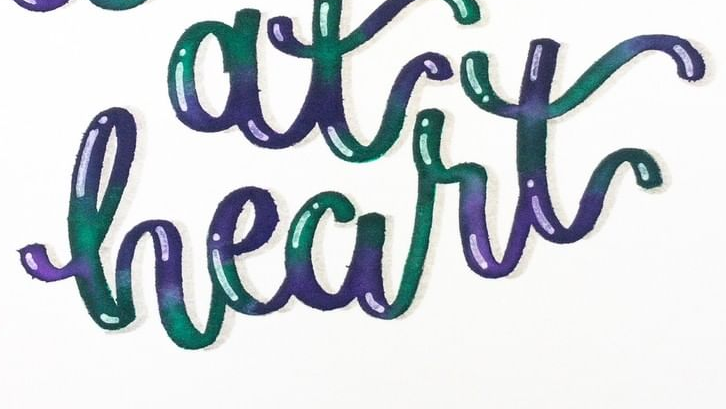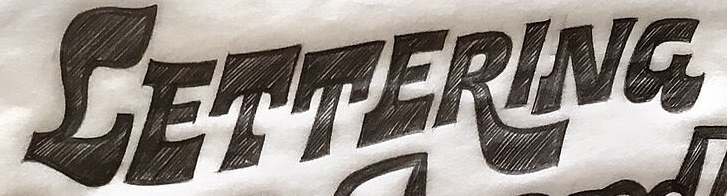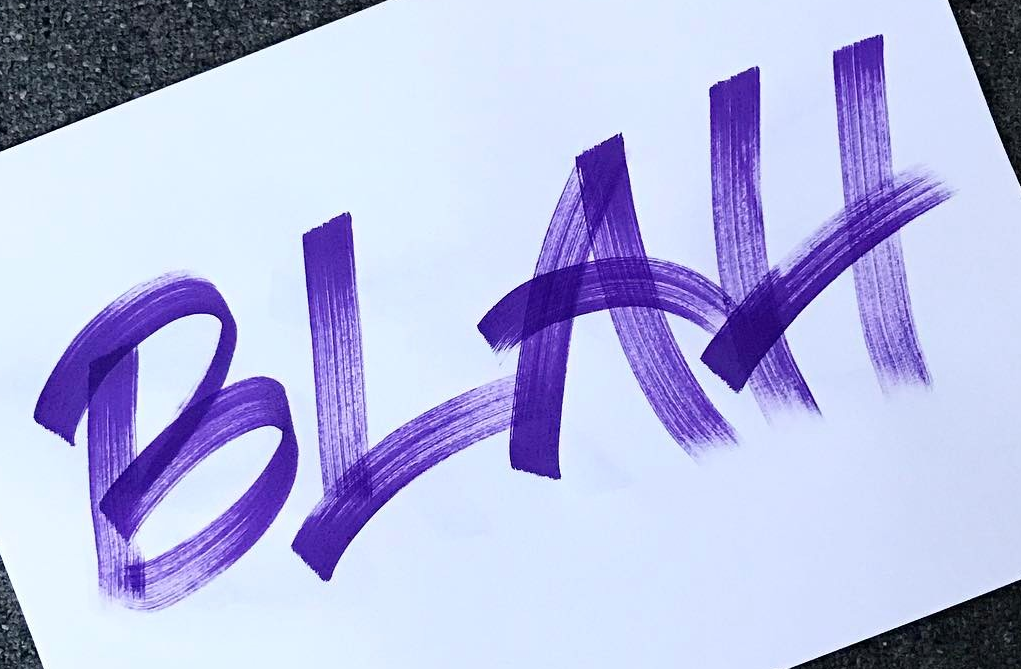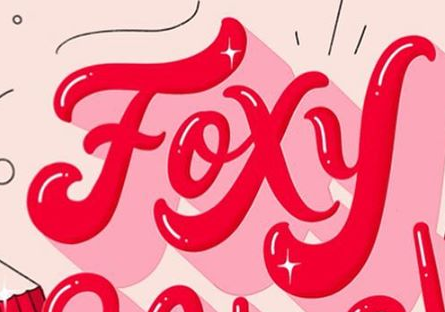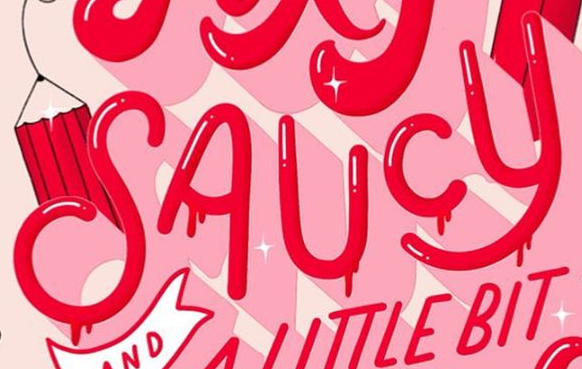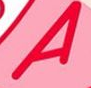What text appears in these images from left to right, separated by a semicolon? heart; CETTERING; BLAH; Foxy; SAUCY; A 